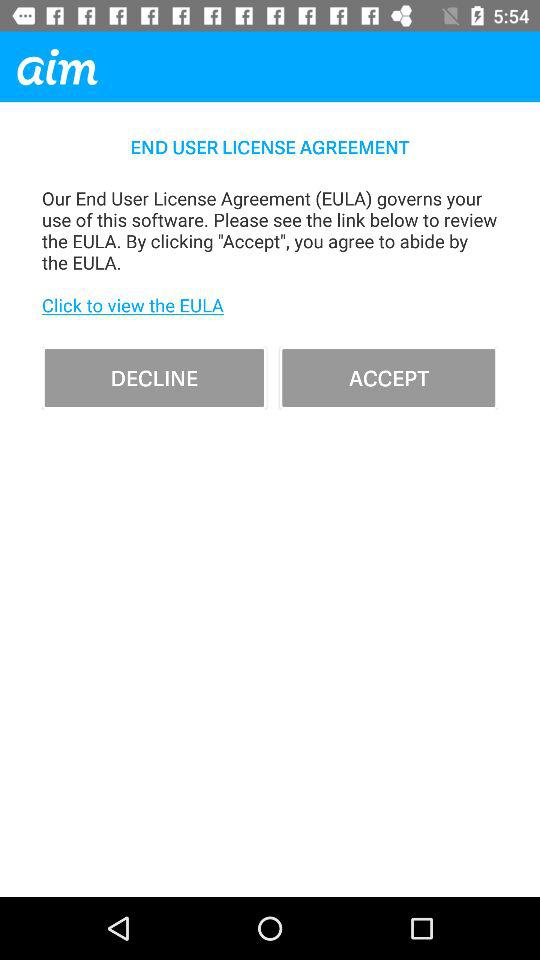What is the full form of EULA? The full form of EULA is End User License Agreement. 